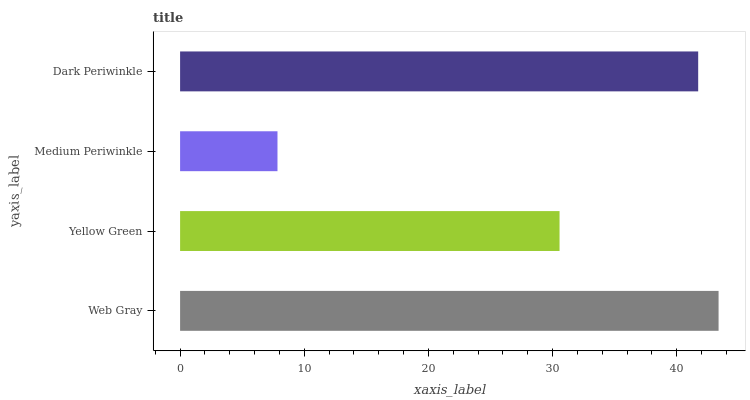Is Medium Periwinkle the minimum?
Answer yes or no. Yes. Is Web Gray the maximum?
Answer yes or no. Yes. Is Yellow Green the minimum?
Answer yes or no. No. Is Yellow Green the maximum?
Answer yes or no. No. Is Web Gray greater than Yellow Green?
Answer yes or no. Yes. Is Yellow Green less than Web Gray?
Answer yes or no. Yes. Is Yellow Green greater than Web Gray?
Answer yes or no. No. Is Web Gray less than Yellow Green?
Answer yes or no. No. Is Dark Periwinkle the high median?
Answer yes or no. Yes. Is Yellow Green the low median?
Answer yes or no. Yes. Is Web Gray the high median?
Answer yes or no. No. Is Web Gray the low median?
Answer yes or no. No. 